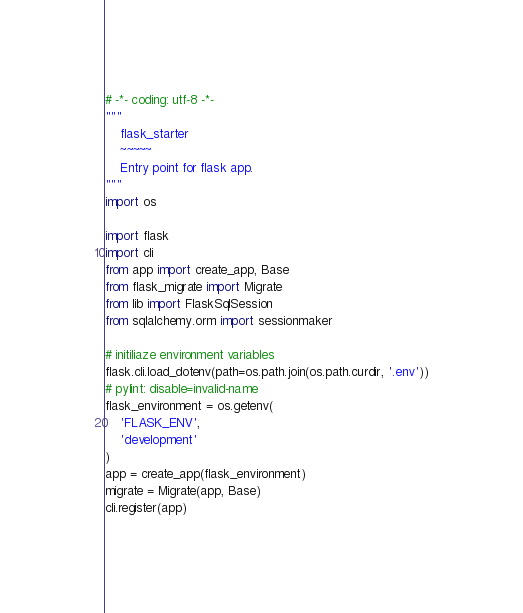<code> <loc_0><loc_0><loc_500><loc_500><_Python_># -*- coding: utf-8 -*-
"""
    flask_starter
    ~~~~~
    Entry point for flask app.
"""
import os

import flask
import cli
from app import create_app, Base
from flask_migrate import Migrate
from lib import FlaskSqlSession
from sqlalchemy.orm import sessionmaker

# initiliaze environment variables
flask.cli.load_dotenv(path=os.path.join(os.path.curdir, '.env'))
# pylint: disable=invalid-name
flask_environment = os.getenv(
    'FLASK_ENV',
    'development'
)
app = create_app(flask_environment)
migrate = Migrate(app, Base)
cli.register(app)
</code> 